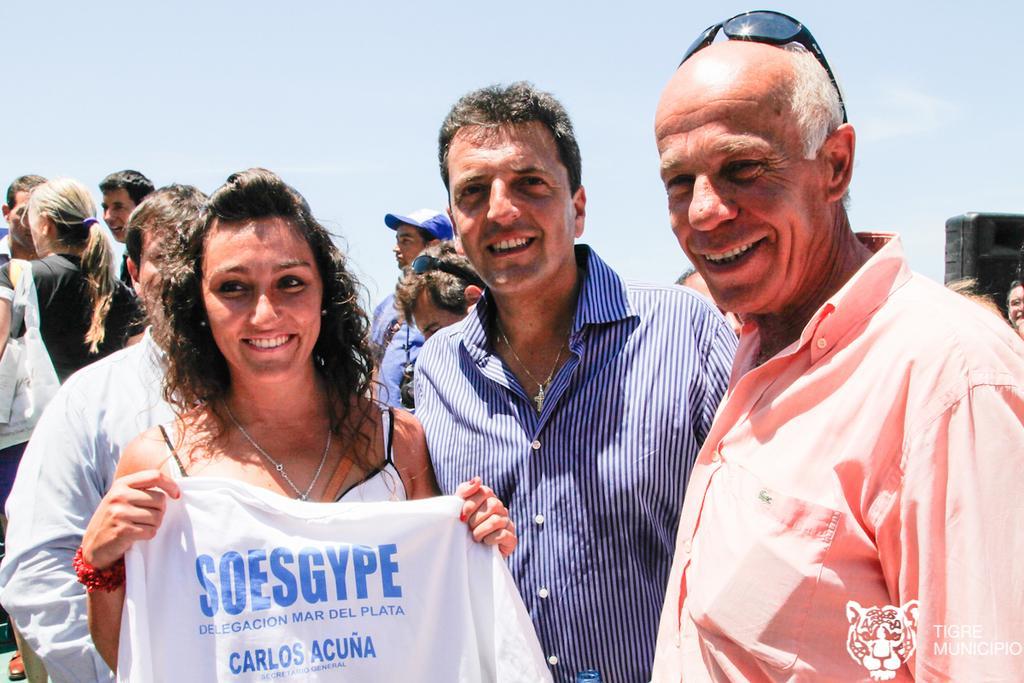Please provide a concise description of this image. In this image we can see people standing and smiling. 